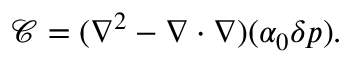Convert formula to latex. <formula><loc_0><loc_0><loc_500><loc_500>\mathcal { C } = ( \nabla ^ { 2 } - \nabla \cdot \nabla ) ( \alpha _ { 0 } \delta p ) .</formula> 